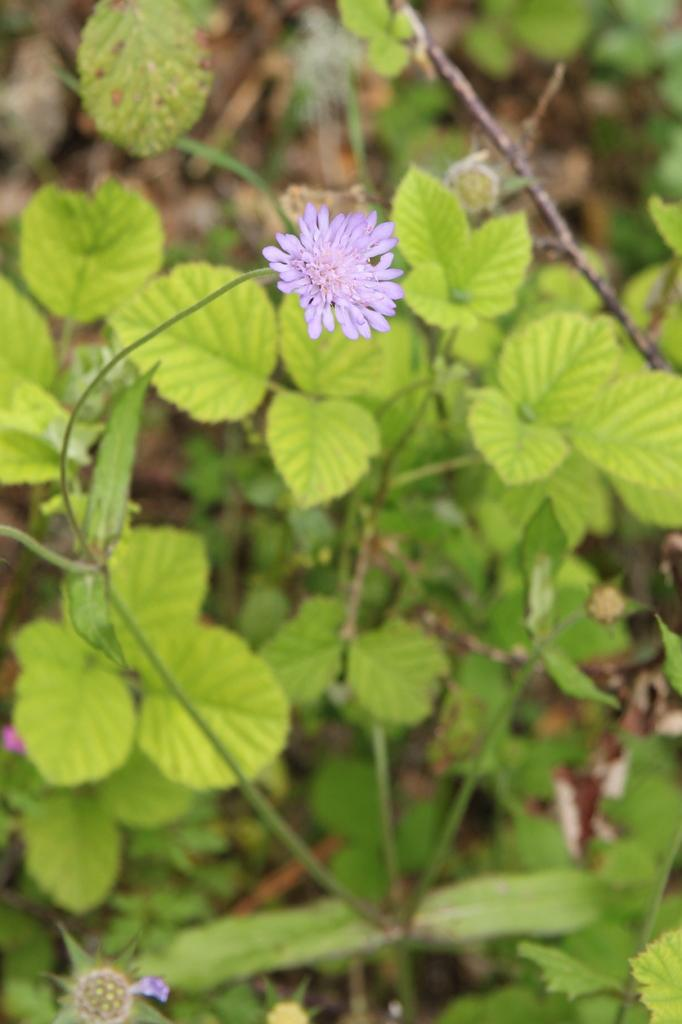What type of living organisms can be seen in the image? Plants and a flower are visible in the image. What color is the flower in the image? The flower is violet in color. What is the tendency of the paper in the image to get wet in the rain? There is no paper present in the image, so it is not possible to determine its tendency to get wet in the rain. 